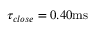Convert formula to latex. <formula><loc_0><loc_0><loc_500><loc_500>\tau _ { c l o s e } = 0 . 4 0 m s</formula> 